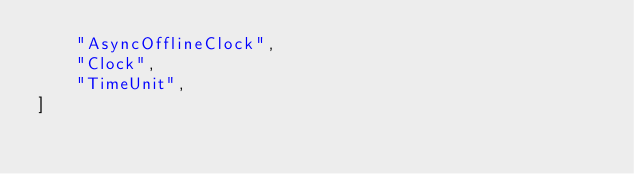Convert code to text. <code><loc_0><loc_0><loc_500><loc_500><_Python_>    "AsyncOfflineClock",
    "Clock",
    "TimeUnit",
]
</code> 